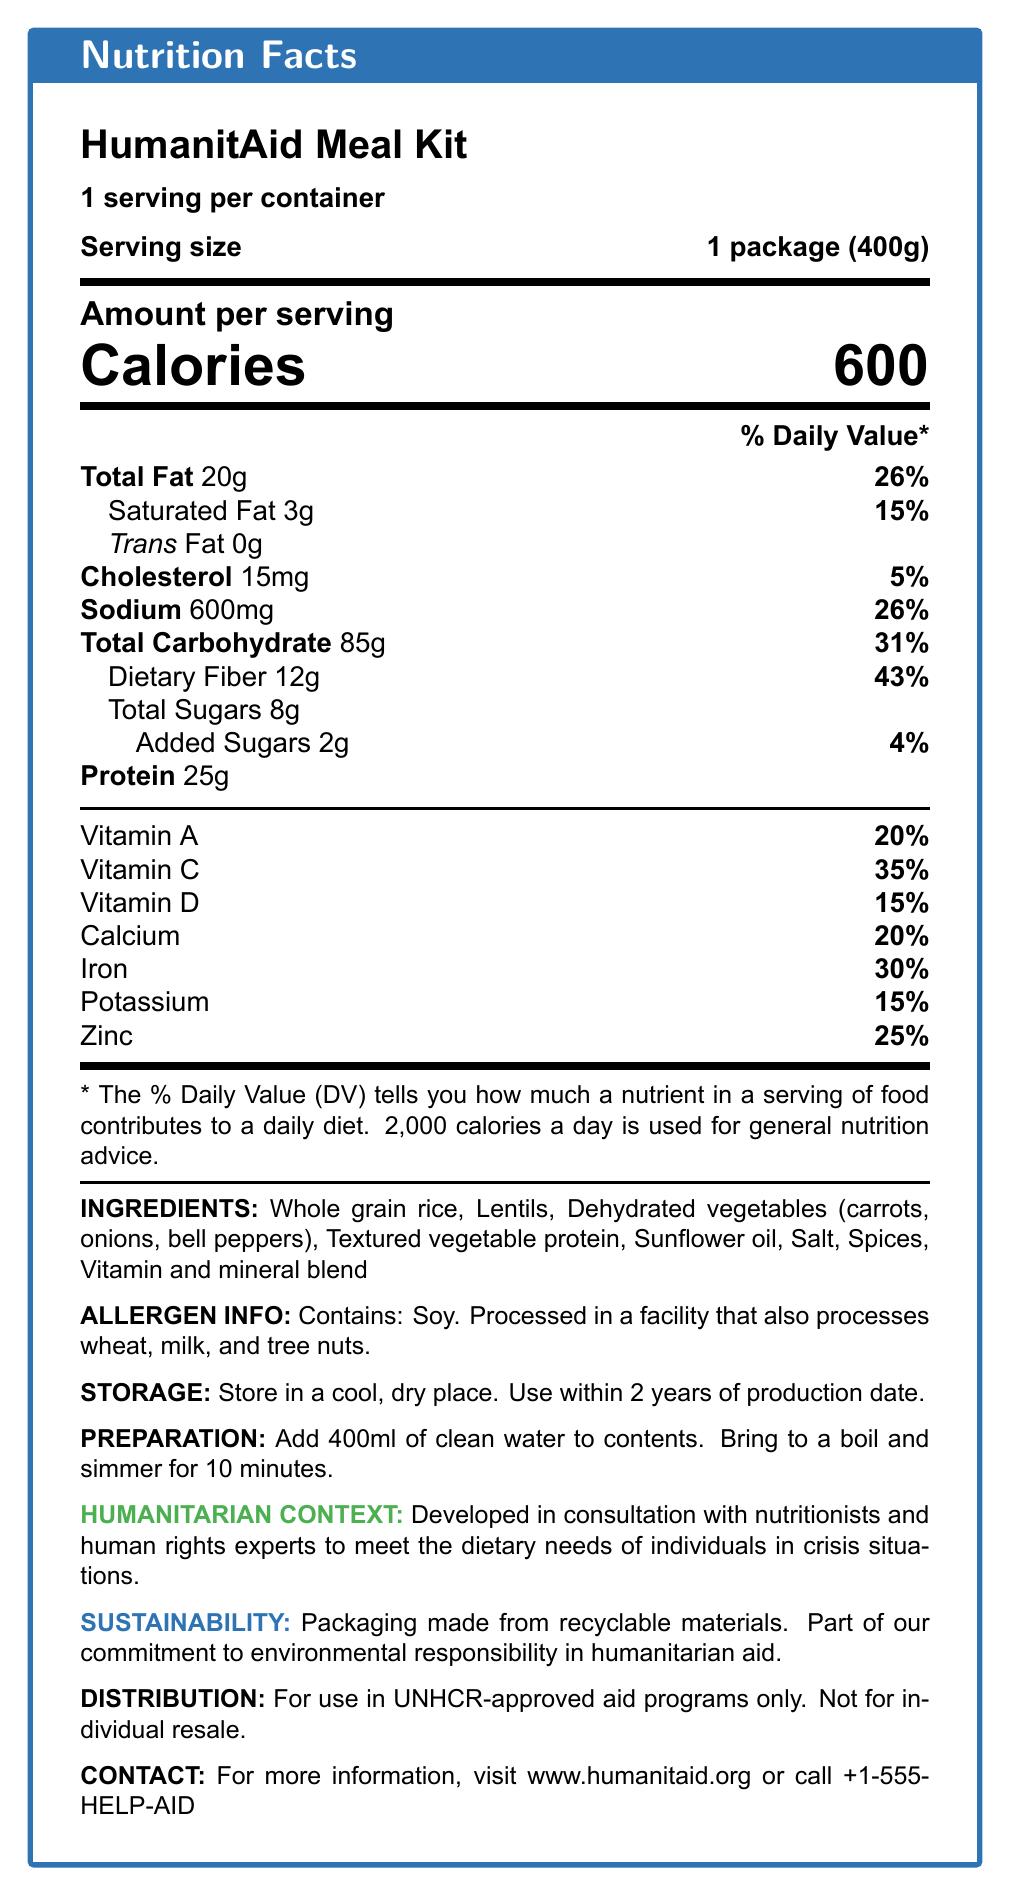what is the total fat content per serving? The total fat content is explicitly listed as "Total Fat 20g" under the nutrition facts.
Answer: 20g what are the main ingredients in the HumanitAid Meal Kit? These ingredients are listed under "INGREDIENTS".
Answer: Whole grain rice, Lentils, Dehydrated vegetables, Textured vegetable protein, Sunflower oil, Salt, Spices, Vitamin and mineral blend how many calories are in one serving of the meal kit? The calories per serving are clearly stated as "Calories 600".
Answer: 600 what is the serving size of the HumanitAid Meal Kit? The serving size is listed as "Serving size 1 package (400g)".
Answer: 1 package (400g) what is the daily value percentage of dietary fiber? The daily value of dietary fiber is listed as "Dietary Fiber 12g 43%".
Answer: 43% which vitamin has the highest daily value percentage in the meal kit? A. Vitamin A B. Vitamin C C. Vitamin D D. Calcium Vitamin C has the highest daily value percentage at 35%.
Answer: B how much sodium does one serving contain? The sodium content is listed as "Sodium 600mg".
Answer: 600mg what allergens are present in the HumanitAid Meal Kit? The allergen information states "Contains: Soy".
Answer: Soy how long can the HumanitAid Meal Kit be stored? The storage section specifies "Use within 2 years of production date".
Answer: 2 years does the package of the HumanitAid Meal Kit need refrigeration? The storage instructions say "Store in a cool, dry place," implying no refrigeration is needed.
Answer: No what is the protein content per serving? The protein amount per serving is listed as "Protein 25g".
Answer: 25g how should the HumanitAid Meal Kit be prepared? The preparation instructions state, "Add 400ml of clean water to contents. Bring to a boil and simmer for 10 minutes."
Answer: Add 400ml of clean water, bring to a boil, and simmer for 10 minutes does the meal kit contain any trans fat? It states "Trans Fat 0g," indicating there is no trans fat.
Answer: No for whom is the HumanitAid Meal Kit intended? A. Individual resale B. Humanitarian organizations approved by UNHCR C. General public The distribution information states "For use in UNHCR-approved aid programs only."
Answer: B what type of packaging is used for the HumanitAid Meal Kit? A. Biodegradable B. Non-recyclable C. Recyclable The sustainability note mentions that the packaging is made from recyclable materials.
Answer: C how many servings are in one container? It clearly states "1 serving per container."
Answer: 1 is the HumanitAid Meal Kit gluten-free? The allergen information mentions processing in a facility that handles wheat, but does not confirm if the meal itself is gluten-free.
Answer: Not enough information provide a summary of the main features of the HumanitAid Meal Kit. The document outlines the nutritional information, ingredients, allergen info, storage and preparation instructions, and the humanitarian and sustainability contexts of the HumanitAid Meal Kit.
Answer: The HumanitAid Meal Kit is a nutrient-dense, shelf-stable meal designed for humanitarian aid distribution. It includes a high amount of fiber and protein, essential vitamins and minerals, and is developed to meet dietary needs of individuals in crisis. It's allergy-friendly, storage-efficient, sustainable with recyclable packaging, and requires simple preparation. It is intended for distribution in UNHCR-approved programs. 